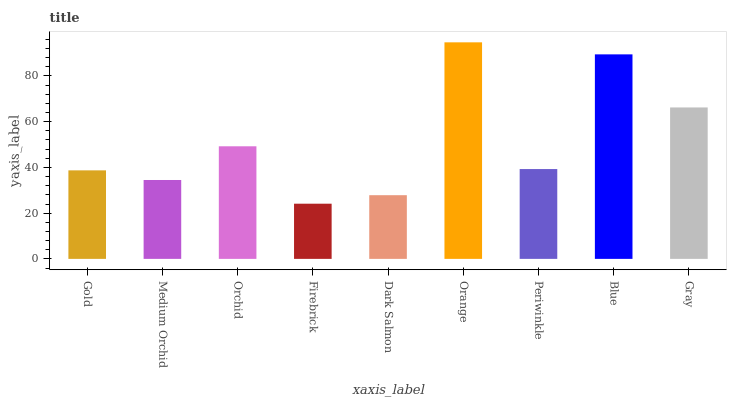Is Firebrick the minimum?
Answer yes or no. Yes. Is Orange the maximum?
Answer yes or no. Yes. Is Medium Orchid the minimum?
Answer yes or no. No. Is Medium Orchid the maximum?
Answer yes or no. No. Is Gold greater than Medium Orchid?
Answer yes or no. Yes. Is Medium Orchid less than Gold?
Answer yes or no. Yes. Is Medium Orchid greater than Gold?
Answer yes or no. No. Is Gold less than Medium Orchid?
Answer yes or no. No. Is Periwinkle the high median?
Answer yes or no. Yes. Is Periwinkle the low median?
Answer yes or no. Yes. Is Firebrick the high median?
Answer yes or no. No. Is Orchid the low median?
Answer yes or no. No. 